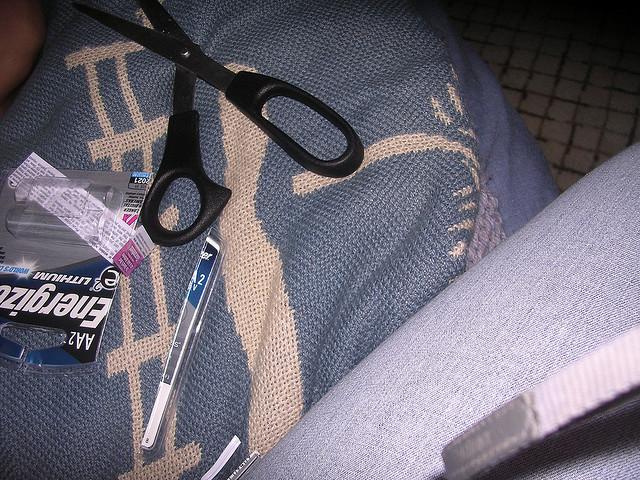What color are the scissors?
Write a very short answer. Black. What were the scissors used for?
Answer briefly. Opening package. What is the battery package type?
Be succinct. Aa. 